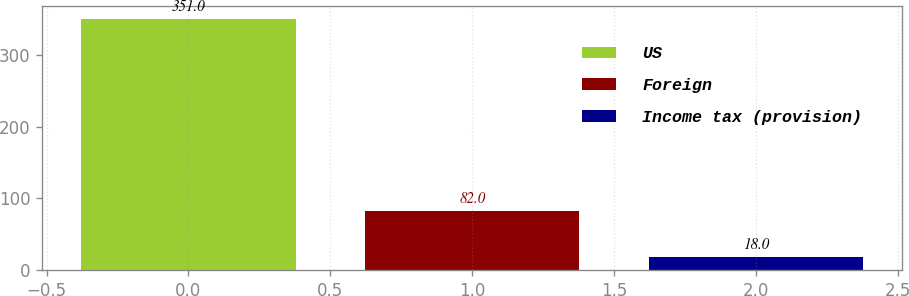Convert chart to OTSL. <chart><loc_0><loc_0><loc_500><loc_500><bar_chart><fcel>US<fcel>Foreign<fcel>Income tax (provision)<nl><fcel>351<fcel>82<fcel>18<nl></chart> 